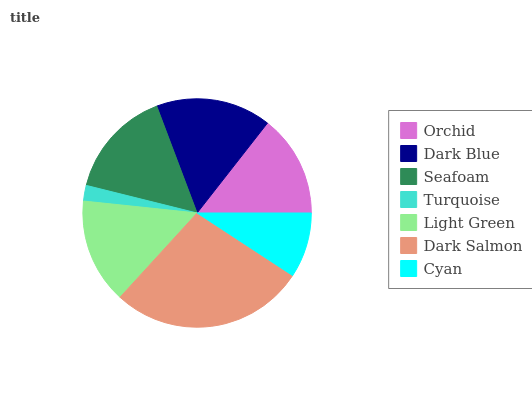Is Turquoise the minimum?
Answer yes or no. Yes. Is Dark Salmon the maximum?
Answer yes or no. Yes. Is Dark Blue the minimum?
Answer yes or no. No. Is Dark Blue the maximum?
Answer yes or no. No. Is Dark Blue greater than Orchid?
Answer yes or no. Yes. Is Orchid less than Dark Blue?
Answer yes or no. Yes. Is Orchid greater than Dark Blue?
Answer yes or no. No. Is Dark Blue less than Orchid?
Answer yes or no. No. Is Light Green the high median?
Answer yes or no. Yes. Is Light Green the low median?
Answer yes or no. Yes. Is Dark Salmon the high median?
Answer yes or no. No. Is Dark Blue the low median?
Answer yes or no. No. 